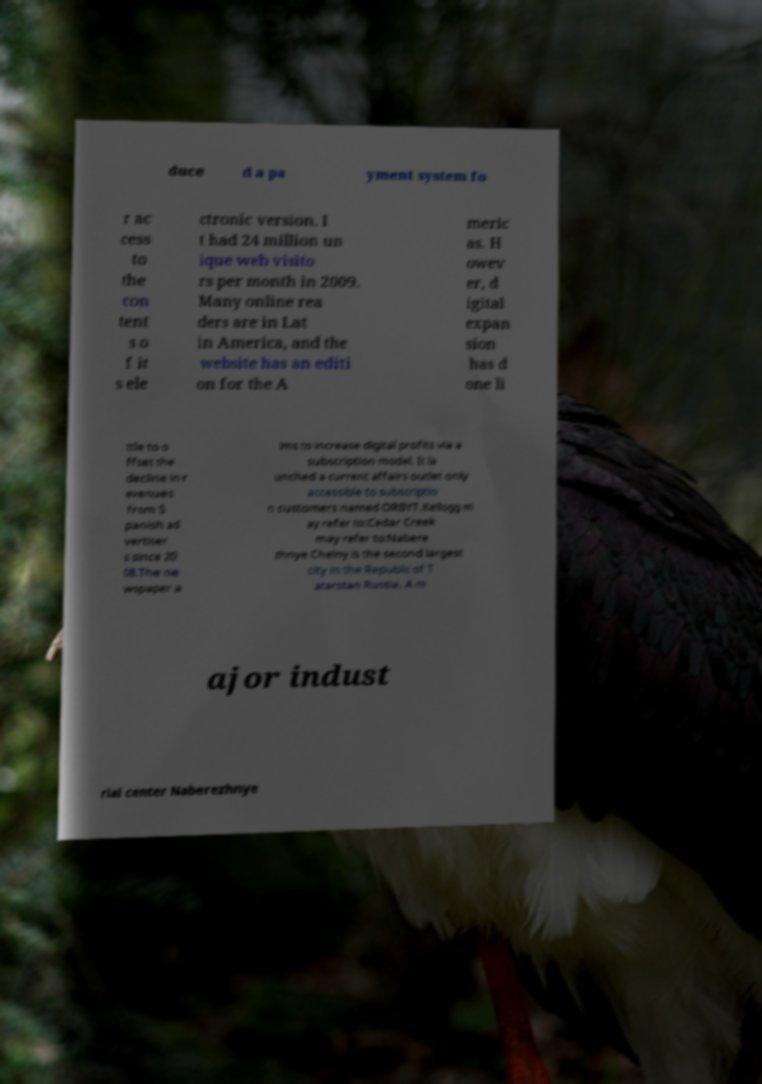Could you extract and type out the text from this image? duce d a pa yment system fo r ac cess to the con tent s o f it s ele ctronic version. I t had 24 million un ique web visito rs per month in 2009. Many online rea ders are in Lat in America, and the website has an editi on for the A meric as. H owev er, d igital expan sion has d one li ttle to o ffset the decline in r evenues from S panish ad vertiser s since 20 08.The ne wspaper a ims to increase digital profits via a subscription model. It la unched a current affairs outlet only accessible to subscriptio n customers named ORBYT.Kellogg m ay refer to:Cedar Creek may refer to:Nabere zhnye Chelny is the second largest city in the Republic of T atarstan Russia. A m ajor indust rial center Naberezhnye 